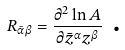<formula> <loc_0><loc_0><loc_500><loc_500>R _ { \bar { \alpha } \beta } = \frac { \partial ^ { 2 } \ln A } { \partial { \bar { z } } ^ { \alpha } { z } ^ { \beta } } \text { .}</formula> 